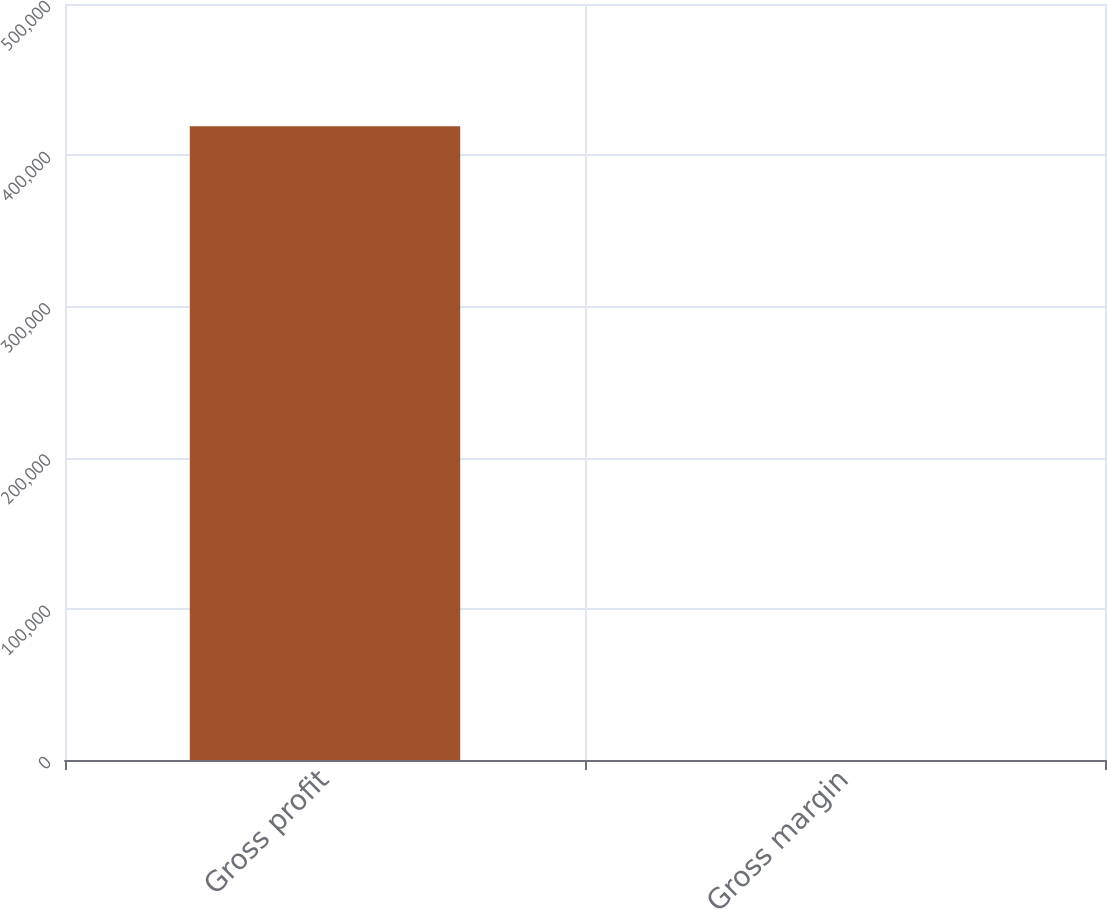Convert chart to OTSL. <chart><loc_0><loc_0><loc_500><loc_500><bar_chart><fcel>Gross profit<fcel>Gross margin<nl><fcel>419172<fcel>34.8<nl></chart> 